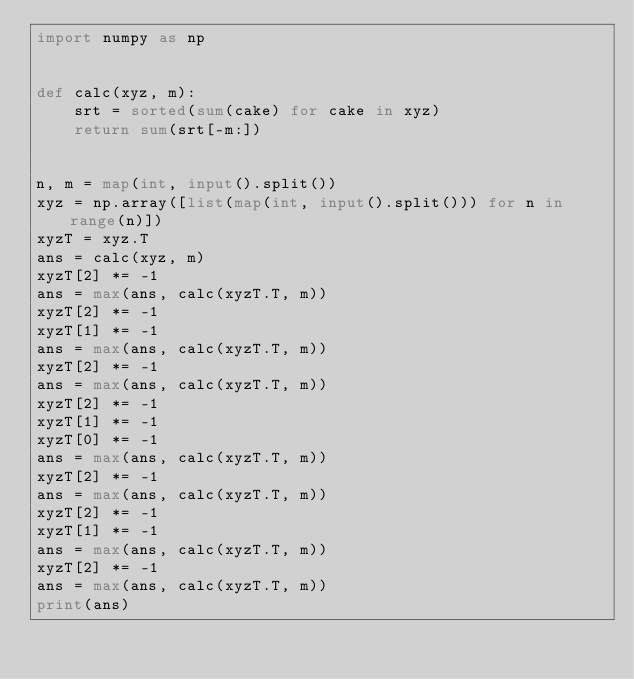Convert code to text. <code><loc_0><loc_0><loc_500><loc_500><_Python_>import numpy as np


def calc(xyz, m):
    srt = sorted(sum(cake) for cake in xyz)
    return sum(srt[-m:])


n, m = map(int, input().split())
xyz = np.array([list(map(int, input().split())) for n in range(n)])
xyzT = xyz.T
ans = calc(xyz, m)
xyzT[2] *= -1
ans = max(ans, calc(xyzT.T, m))
xyzT[2] *= -1
xyzT[1] *= -1
ans = max(ans, calc(xyzT.T, m))
xyzT[2] *= -1
ans = max(ans, calc(xyzT.T, m))
xyzT[2] *= -1
xyzT[1] *= -1
xyzT[0] *= -1
ans = max(ans, calc(xyzT.T, m))
xyzT[2] *= -1
ans = max(ans, calc(xyzT.T, m))
xyzT[2] *= -1
xyzT[1] *= -1
ans = max(ans, calc(xyzT.T, m))
xyzT[2] *= -1
ans = max(ans, calc(xyzT.T, m))
print(ans)
</code> 